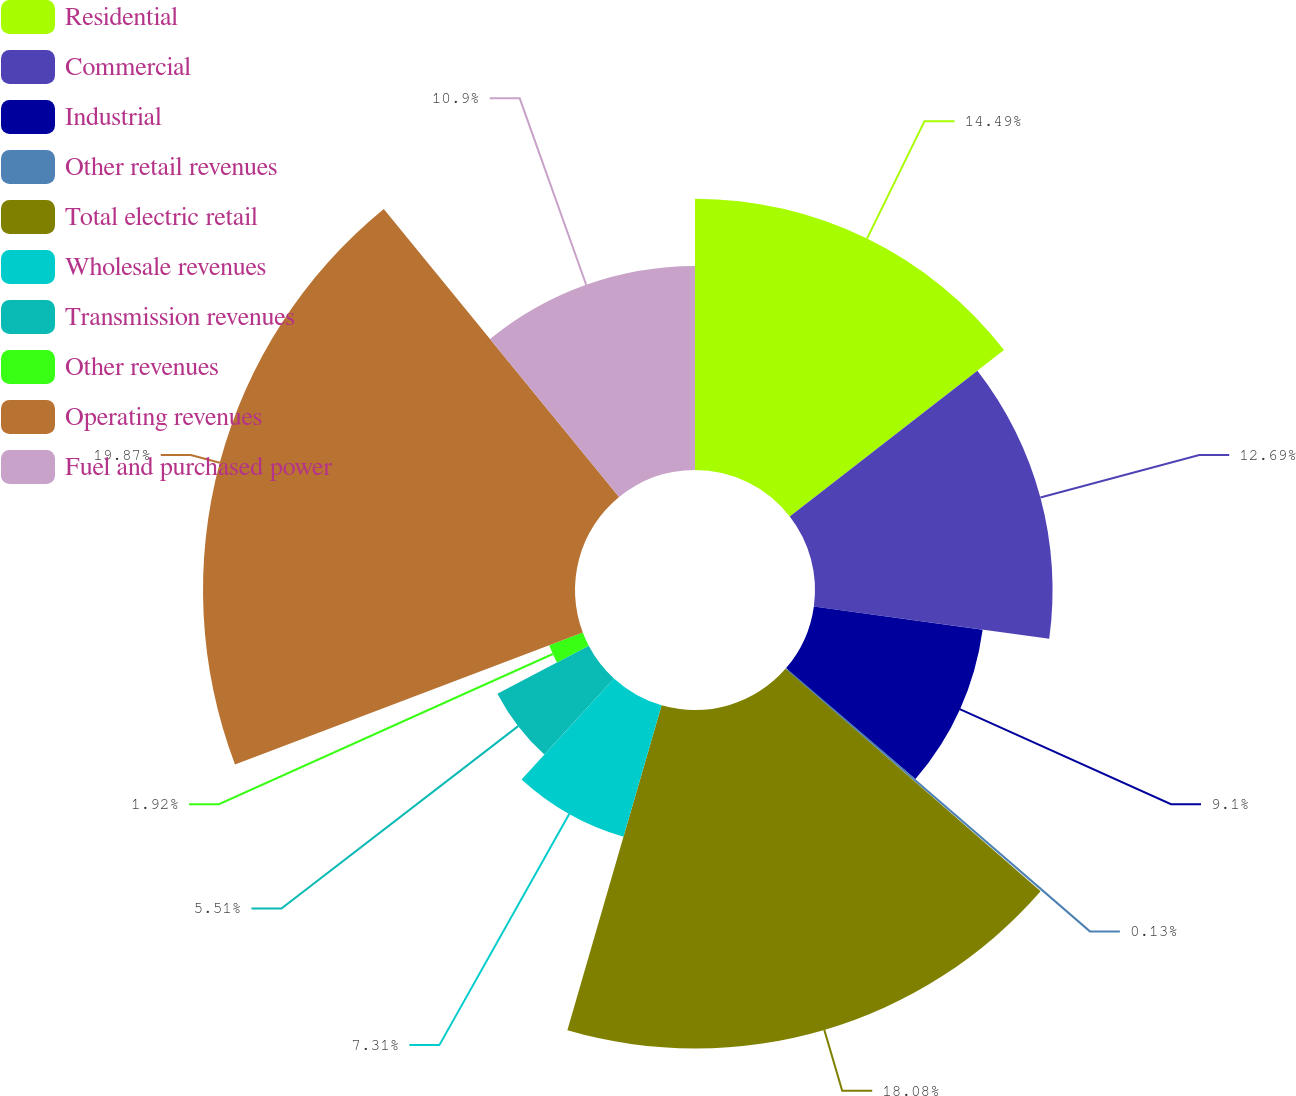<chart> <loc_0><loc_0><loc_500><loc_500><pie_chart><fcel>Residential<fcel>Commercial<fcel>Industrial<fcel>Other retail revenues<fcel>Total electric retail<fcel>Wholesale revenues<fcel>Transmission revenues<fcel>Other revenues<fcel>Operating revenues<fcel>Fuel and purchased power<nl><fcel>14.49%<fcel>12.69%<fcel>9.1%<fcel>0.13%<fcel>18.08%<fcel>7.31%<fcel>5.51%<fcel>1.92%<fcel>19.87%<fcel>10.9%<nl></chart> 